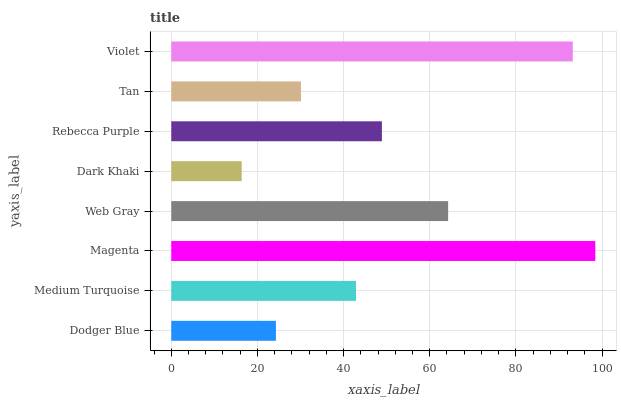Is Dark Khaki the minimum?
Answer yes or no. Yes. Is Magenta the maximum?
Answer yes or no. Yes. Is Medium Turquoise the minimum?
Answer yes or no. No. Is Medium Turquoise the maximum?
Answer yes or no. No. Is Medium Turquoise greater than Dodger Blue?
Answer yes or no. Yes. Is Dodger Blue less than Medium Turquoise?
Answer yes or no. Yes. Is Dodger Blue greater than Medium Turquoise?
Answer yes or no. No. Is Medium Turquoise less than Dodger Blue?
Answer yes or no. No. Is Rebecca Purple the high median?
Answer yes or no. Yes. Is Medium Turquoise the low median?
Answer yes or no. Yes. Is Web Gray the high median?
Answer yes or no. No. Is Tan the low median?
Answer yes or no. No. 